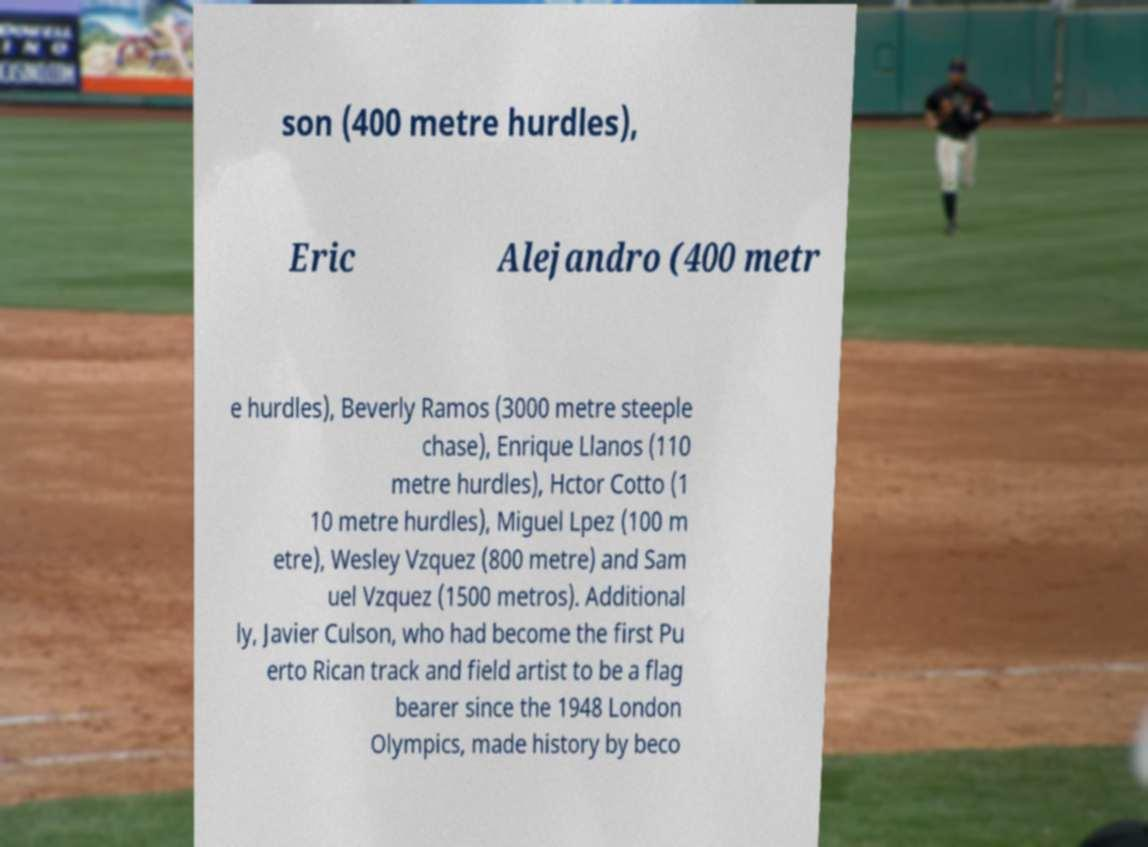Please identify and transcribe the text found in this image. son (400 metre hurdles), Eric Alejandro (400 metr e hurdles), Beverly Ramos (3000 metre steeple chase), Enrique Llanos (110 metre hurdles), Hctor Cotto (1 10 metre hurdles), Miguel Lpez (100 m etre), Wesley Vzquez (800 metre) and Sam uel Vzquez (1500 metros). Additional ly, Javier Culson, who had become the first Pu erto Rican track and field artist to be a flag bearer since the 1948 London Olympics, made history by beco 